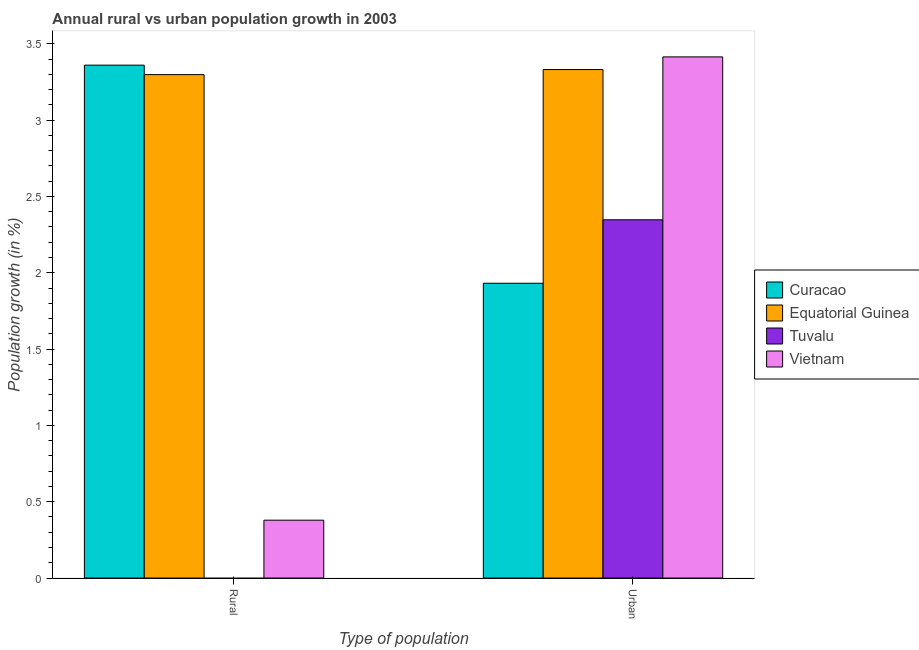How many different coloured bars are there?
Keep it short and to the point. 4. Are the number of bars per tick equal to the number of legend labels?
Offer a terse response. No. Are the number of bars on each tick of the X-axis equal?
Provide a succinct answer. No. How many bars are there on the 1st tick from the right?
Offer a terse response. 4. What is the label of the 2nd group of bars from the left?
Give a very brief answer. Urban . What is the urban population growth in Tuvalu?
Offer a very short reply. 2.35. Across all countries, what is the maximum rural population growth?
Offer a very short reply. 3.36. Across all countries, what is the minimum rural population growth?
Ensure brevity in your answer.  0. In which country was the urban population growth maximum?
Provide a short and direct response. Vietnam. What is the total urban population growth in the graph?
Ensure brevity in your answer.  11.02. What is the difference between the urban population growth in Curacao and that in Tuvalu?
Give a very brief answer. -0.42. What is the difference between the rural population growth in Tuvalu and the urban population growth in Vietnam?
Keep it short and to the point. -3.41. What is the average urban population growth per country?
Offer a very short reply. 2.76. What is the difference between the rural population growth and urban population growth in Equatorial Guinea?
Your response must be concise. -0.03. In how many countries, is the rural population growth greater than 2.9 %?
Make the answer very short. 2. What is the ratio of the rural population growth in Equatorial Guinea to that in Curacao?
Make the answer very short. 0.98. In how many countries, is the urban population growth greater than the average urban population growth taken over all countries?
Keep it short and to the point. 2. Are the values on the major ticks of Y-axis written in scientific E-notation?
Your response must be concise. No. Does the graph contain any zero values?
Provide a short and direct response. Yes. Does the graph contain grids?
Offer a terse response. No. Where does the legend appear in the graph?
Ensure brevity in your answer.  Center right. How many legend labels are there?
Your answer should be very brief. 4. How are the legend labels stacked?
Provide a succinct answer. Vertical. What is the title of the graph?
Provide a short and direct response. Annual rural vs urban population growth in 2003. What is the label or title of the X-axis?
Provide a short and direct response. Type of population. What is the label or title of the Y-axis?
Offer a very short reply. Population growth (in %). What is the Population growth (in %) in Curacao in Rural?
Your response must be concise. 3.36. What is the Population growth (in %) of Equatorial Guinea in Rural?
Your answer should be very brief. 3.3. What is the Population growth (in %) in Tuvalu in Rural?
Ensure brevity in your answer.  0. What is the Population growth (in %) in Vietnam in Rural?
Your answer should be compact. 0.38. What is the Population growth (in %) in Curacao in Urban ?
Your response must be concise. 1.93. What is the Population growth (in %) in Equatorial Guinea in Urban ?
Give a very brief answer. 3.33. What is the Population growth (in %) of Tuvalu in Urban ?
Provide a short and direct response. 2.35. What is the Population growth (in %) in Vietnam in Urban ?
Offer a terse response. 3.41. Across all Type of population, what is the maximum Population growth (in %) in Curacao?
Make the answer very short. 3.36. Across all Type of population, what is the maximum Population growth (in %) of Equatorial Guinea?
Your response must be concise. 3.33. Across all Type of population, what is the maximum Population growth (in %) of Tuvalu?
Offer a terse response. 2.35. Across all Type of population, what is the maximum Population growth (in %) in Vietnam?
Make the answer very short. 3.41. Across all Type of population, what is the minimum Population growth (in %) of Curacao?
Your answer should be compact. 1.93. Across all Type of population, what is the minimum Population growth (in %) in Equatorial Guinea?
Give a very brief answer. 3.3. Across all Type of population, what is the minimum Population growth (in %) in Tuvalu?
Keep it short and to the point. 0. Across all Type of population, what is the minimum Population growth (in %) of Vietnam?
Your response must be concise. 0.38. What is the total Population growth (in %) of Curacao in the graph?
Your answer should be compact. 5.29. What is the total Population growth (in %) of Equatorial Guinea in the graph?
Provide a short and direct response. 6.63. What is the total Population growth (in %) in Tuvalu in the graph?
Your response must be concise. 2.35. What is the total Population growth (in %) in Vietnam in the graph?
Provide a short and direct response. 3.79. What is the difference between the Population growth (in %) in Curacao in Rural and that in Urban ?
Give a very brief answer. 1.43. What is the difference between the Population growth (in %) of Equatorial Guinea in Rural and that in Urban ?
Keep it short and to the point. -0.03. What is the difference between the Population growth (in %) of Vietnam in Rural and that in Urban ?
Offer a terse response. -3.03. What is the difference between the Population growth (in %) of Curacao in Rural and the Population growth (in %) of Equatorial Guinea in Urban?
Your response must be concise. 0.03. What is the difference between the Population growth (in %) of Curacao in Rural and the Population growth (in %) of Tuvalu in Urban?
Keep it short and to the point. 1.01. What is the difference between the Population growth (in %) of Curacao in Rural and the Population growth (in %) of Vietnam in Urban?
Your answer should be very brief. -0.05. What is the difference between the Population growth (in %) in Equatorial Guinea in Rural and the Population growth (in %) in Tuvalu in Urban?
Your answer should be very brief. 0.95. What is the difference between the Population growth (in %) of Equatorial Guinea in Rural and the Population growth (in %) of Vietnam in Urban?
Your answer should be very brief. -0.12. What is the average Population growth (in %) in Curacao per Type of population?
Your answer should be very brief. 2.65. What is the average Population growth (in %) in Equatorial Guinea per Type of population?
Provide a short and direct response. 3.31. What is the average Population growth (in %) of Tuvalu per Type of population?
Offer a very short reply. 1.17. What is the average Population growth (in %) in Vietnam per Type of population?
Offer a terse response. 1.9. What is the difference between the Population growth (in %) in Curacao and Population growth (in %) in Equatorial Guinea in Rural?
Make the answer very short. 0.06. What is the difference between the Population growth (in %) of Curacao and Population growth (in %) of Vietnam in Rural?
Ensure brevity in your answer.  2.98. What is the difference between the Population growth (in %) in Equatorial Guinea and Population growth (in %) in Vietnam in Rural?
Your answer should be compact. 2.92. What is the difference between the Population growth (in %) of Curacao and Population growth (in %) of Equatorial Guinea in Urban ?
Keep it short and to the point. -1.4. What is the difference between the Population growth (in %) in Curacao and Population growth (in %) in Tuvalu in Urban ?
Make the answer very short. -0.42. What is the difference between the Population growth (in %) in Curacao and Population growth (in %) in Vietnam in Urban ?
Your answer should be very brief. -1.48. What is the difference between the Population growth (in %) of Equatorial Guinea and Population growth (in %) of Tuvalu in Urban ?
Make the answer very short. 0.98. What is the difference between the Population growth (in %) in Equatorial Guinea and Population growth (in %) in Vietnam in Urban ?
Provide a succinct answer. -0.08. What is the difference between the Population growth (in %) of Tuvalu and Population growth (in %) of Vietnam in Urban ?
Your answer should be compact. -1.07. What is the ratio of the Population growth (in %) of Curacao in Rural to that in Urban ?
Your answer should be compact. 1.74. What is the ratio of the Population growth (in %) in Vietnam in Rural to that in Urban ?
Your answer should be compact. 0.11. What is the difference between the highest and the second highest Population growth (in %) in Curacao?
Make the answer very short. 1.43. What is the difference between the highest and the second highest Population growth (in %) in Equatorial Guinea?
Your response must be concise. 0.03. What is the difference between the highest and the second highest Population growth (in %) in Vietnam?
Give a very brief answer. 3.03. What is the difference between the highest and the lowest Population growth (in %) in Curacao?
Your response must be concise. 1.43. What is the difference between the highest and the lowest Population growth (in %) in Equatorial Guinea?
Give a very brief answer. 0.03. What is the difference between the highest and the lowest Population growth (in %) in Tuvalu?
Your answer should be very brief. 2.35. What is the difference between the highest and the lowest Population growth (in %) in Vietnam?
Provide a succinct answer. 3.03. 